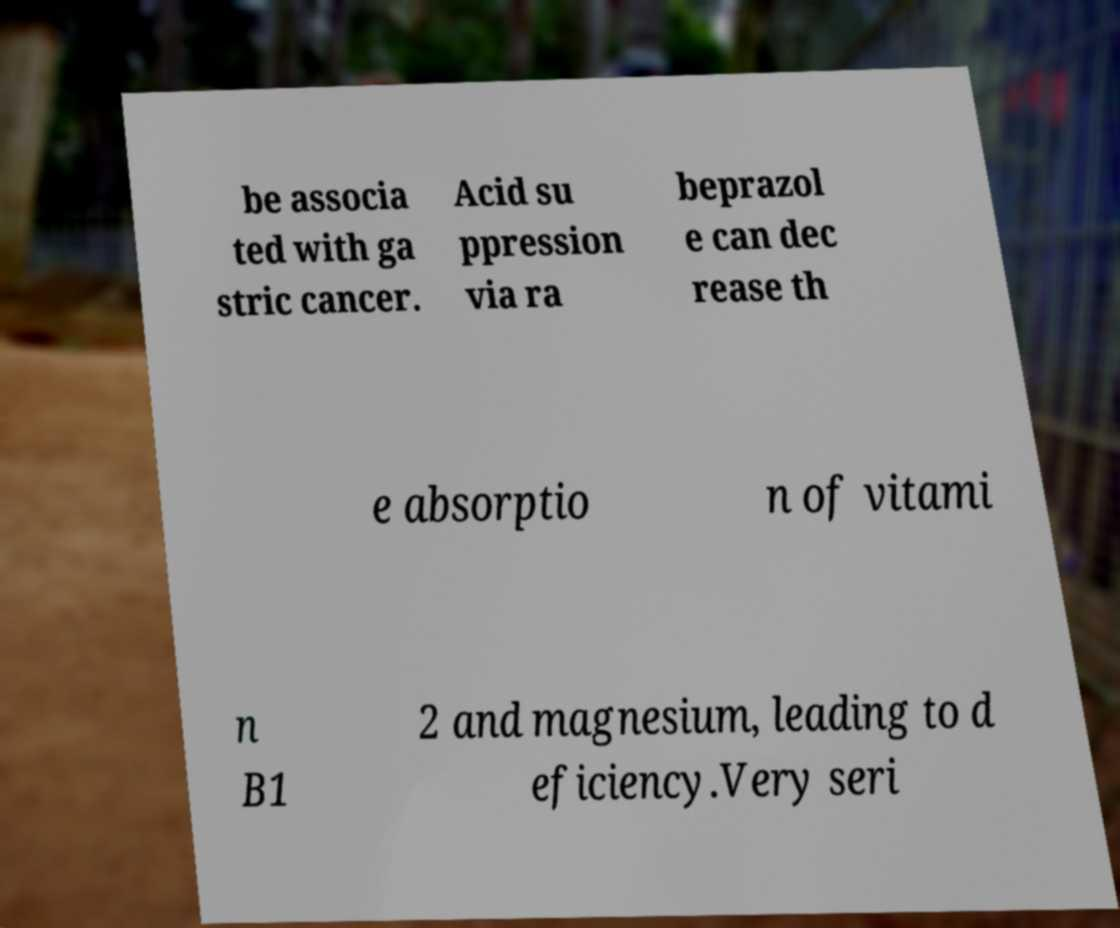Could you assist in decoding the text presented in this image and type it out clearly? be associa ted with ga stric cancer. Acid su ppression via ra beprazol e can dec rease th e absorptio n of vitami n B1 2 and magnesium, leading to d eficiency.Very seri 